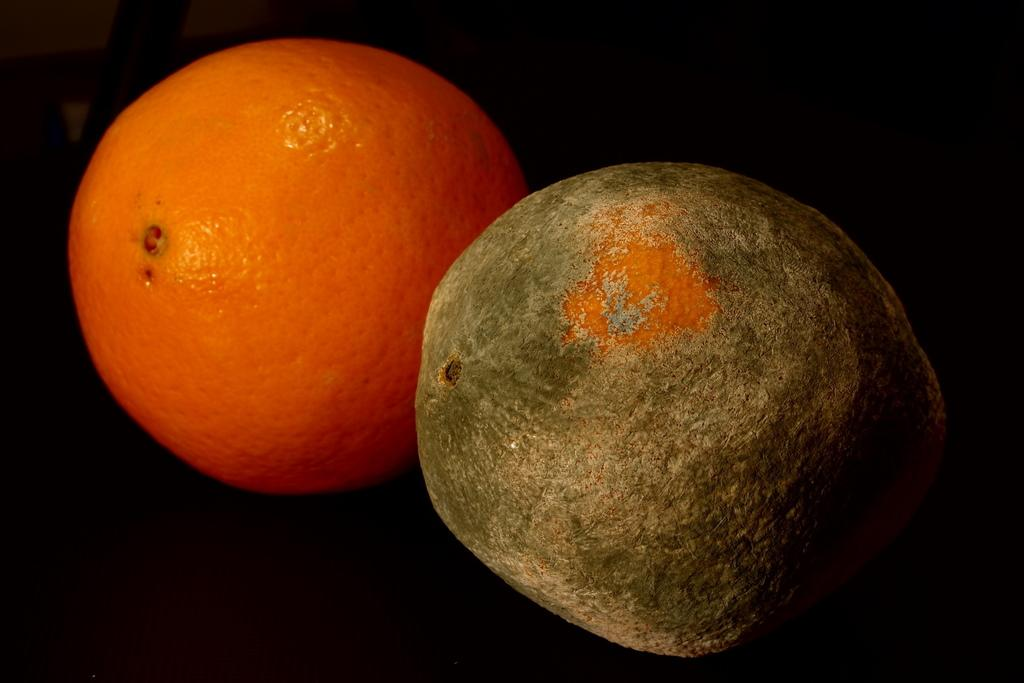What type of fruit is present in the image? There are two oranges in the image. What is the color of the surface on which the oranges are placed? The oranges are on a black surface. How can you tell that one of the oranges is a ripened fruit? One of the oranges is a ripened fruit, as it has a bright orange color and may have a slightly softer texture compared to the other orange. Are there any bears playing chess in the image? No, there are no bears or chess pieces present in the image. 